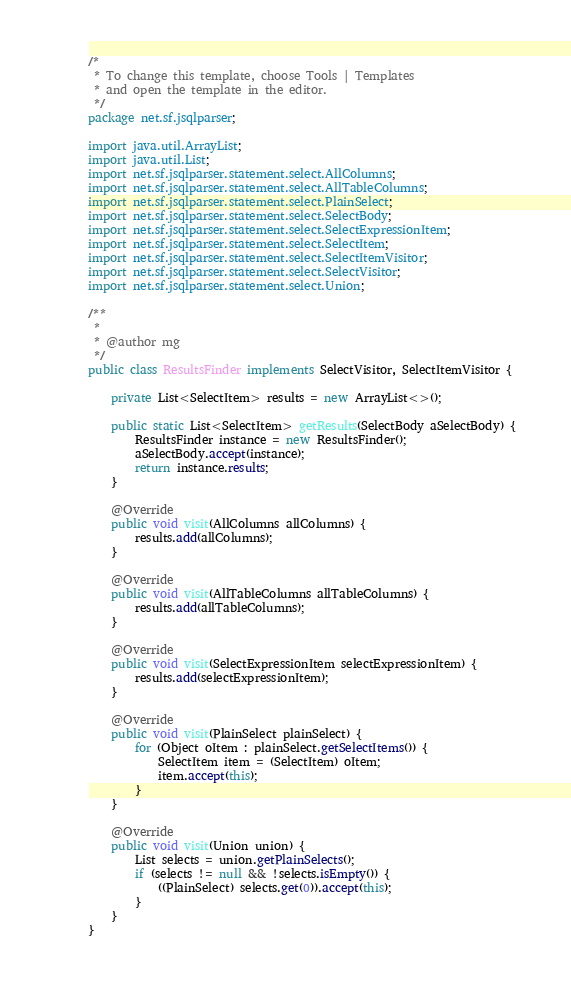Convert code to text. <code><loc_0><loc_0><loc_500><loc_500><_Java_>/*
 * To change this template, choose Tools | Templates
 * and open the template in the editor.
 */
package net.sf.jsqlparser;

import java.util.ArrayList;
import java.util.List;
import net.sf.jsqlparser.statement.select.AllColumns;
import net.sf.jsqlparser.statement.select.AllTableColumns;
import net.sf.jsqlparser.statement.select.PlainSelect;
import net.sf.jsqlparser.statement.select.SelectBody;
import net.sf.jsqlparser.statement.select.SelectExpressionItem;
import net.sf.jsqlparser.statement.select.SelectItem;
import net.sf.jsqlparser.statement.select.SelectItemVisitor;
import net.sf.jsqlparser.statement.select.SelectVisitor;
import net.sf.jsqlparser.statement.select.Union;

/**
 *
 * @author mg
 */
public class ResultsFinder implements SelectVisitor, SelectItemVisitor {

    private List<SelectItem> results = new ArrayList<>();

    public static List<SelectItem> getResults(SelectBody aSelectBody) {
        ResultsFinder instance = new ResultsFinder();
        aSelectBody.accept(instance);
        return instance.results;
    }

    @Override
    public void visit(AllColumns allColumns) {
        results.add(allColumns);
    }

    @Override
    public void visit(AllTableColumns allTableColumns) {
        results.add(allTableColumns);
    }

    @Override
    public void visit(SelectExpressionItem selectExpressionItem) {
        results.add(selectExpressionItem);
    }

    @Override
    public void visit(PlainSelect plainSelect) {
        for (Object oItem : plainSelect.getSelectItems()) {
            SelectItem item = (SelectItem) oItem;
            item.accept(this);
        }
    }

    @Override
    public void visit(Union union) {
        List selects = union.getPlainSelects();
        if (selects != null && !selects.isEmpty()) {
            ((PlainSelect) selects.get(0)).accept(this);
        }
    }
}
</code> 